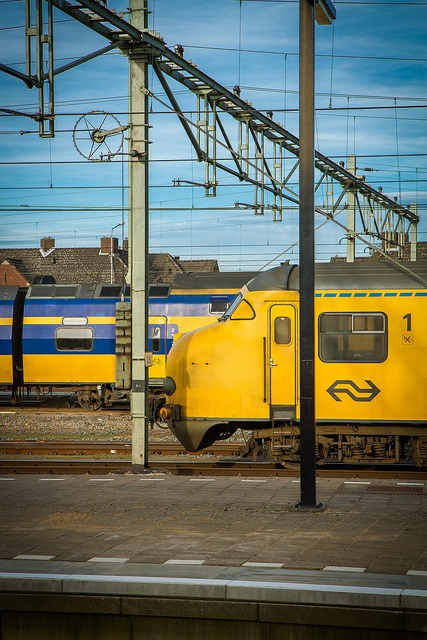Describe the objects in this image and their specific colors. I can see train in teal, orange, black, gold, and olive tones and train in teal, black, orange, and gray tones in this image. 